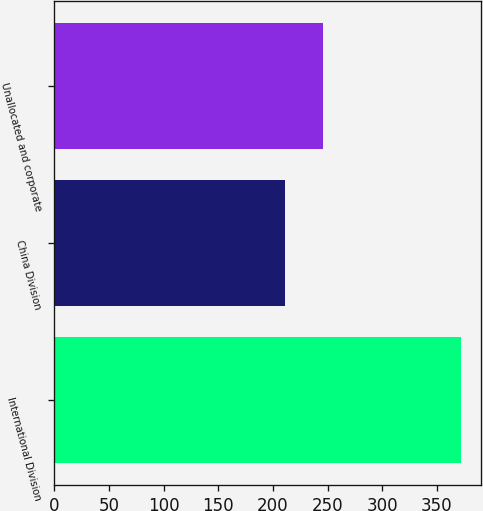<chart> <loc_0><loc_0><loc_500><loc_500><bar_chart><fcel>International Division<fcel>China Division<fcel>Unallocated and corporate<nl><fcel>372<fcel>211<fcel>246<nl></chart> 